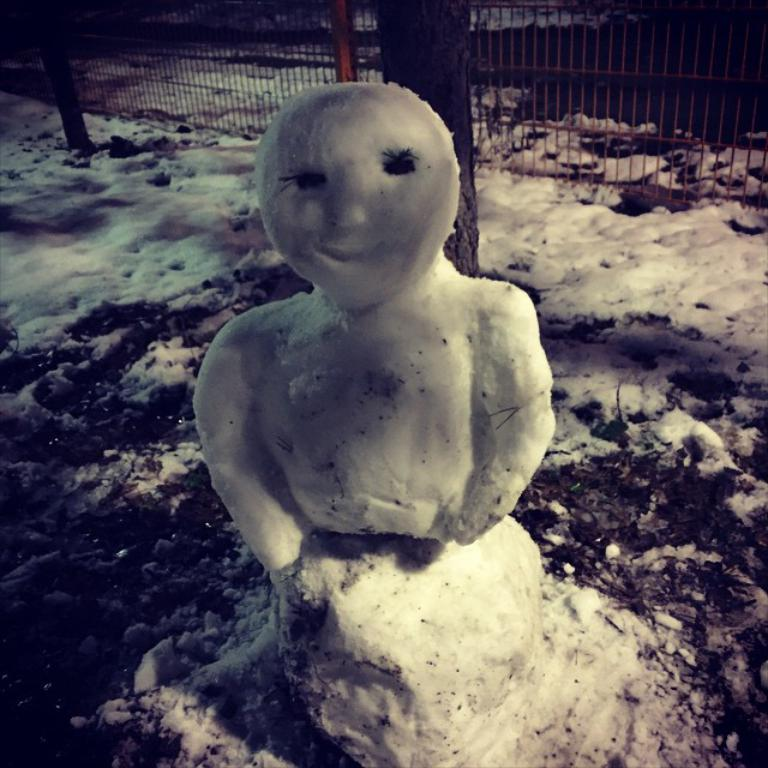What is the main subject of the image? There is a statue of a person in the image. What material is the statue made of? The statue is made of ice. What can be seen in the background of the image? There is a tree trunk and railing in the background of the image. What is present on the ground in the background of the image? There is ice on the ground in the background of the image. What type of tin can be seen being used by the spy in the image? There is no tin or spy present in the image; it features a statue made of ice and a background with a tree trunk, railing, and ice on the ground. 